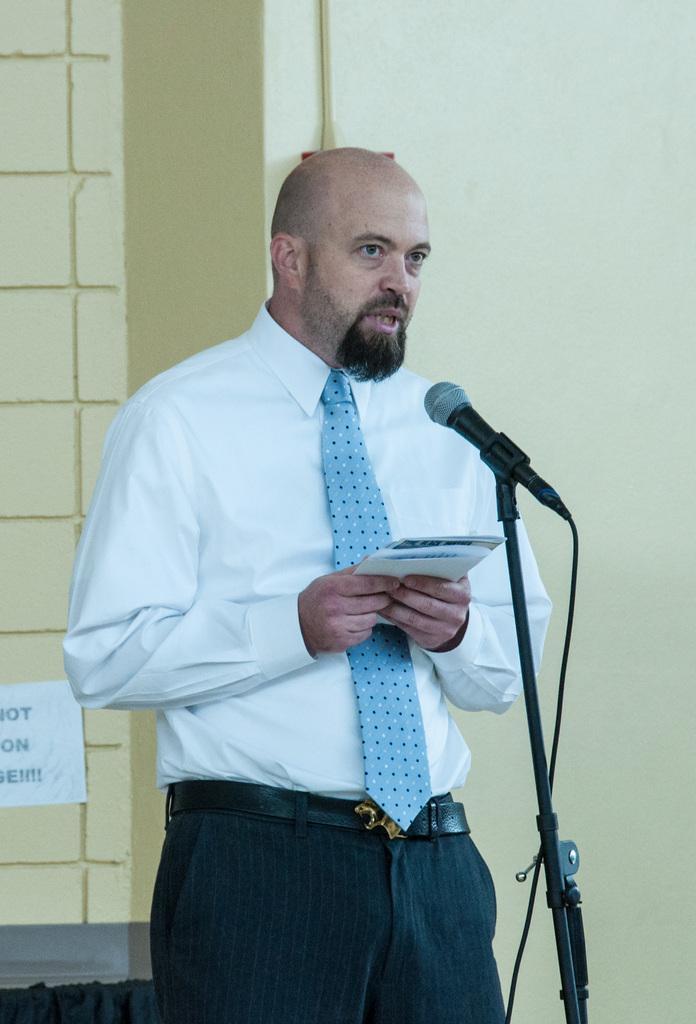How would you summarize this image in a sentence or two? In this picture we can see a man, he is holding papers, in front of him we can see a microphone, in the background we can see a pipe on the wall. 